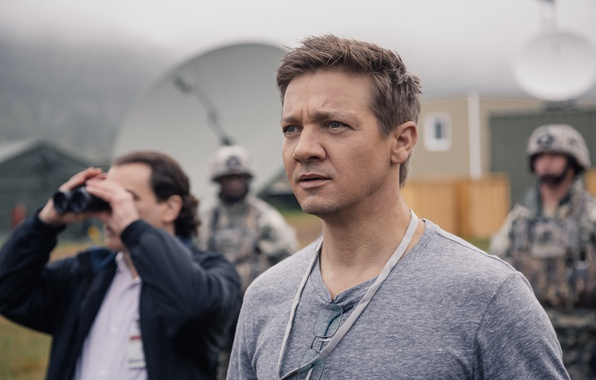Write a detailed description of the given image. In the image, the focal point is a man with a serious expression, looking off to the left. He wears a gray t-shirt and a lanyard that suggests an identification or access pass. The setting appears to be a sophisticated operation area, possibly a military base, as indicated by the presence of personnel in military uniforms. One individual in the background holds binoculars, seemingly observing something in the distance. The environment is equipped with satellite dishes and advanced communication gear. The overall color palette, dominated by gray and green hues, underscores the serious and operational nature of the scene. 